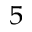Convert formula to latex. <formula><loc_0><loc_0><loc_500><loc_500>^ { 5 }</formula> 